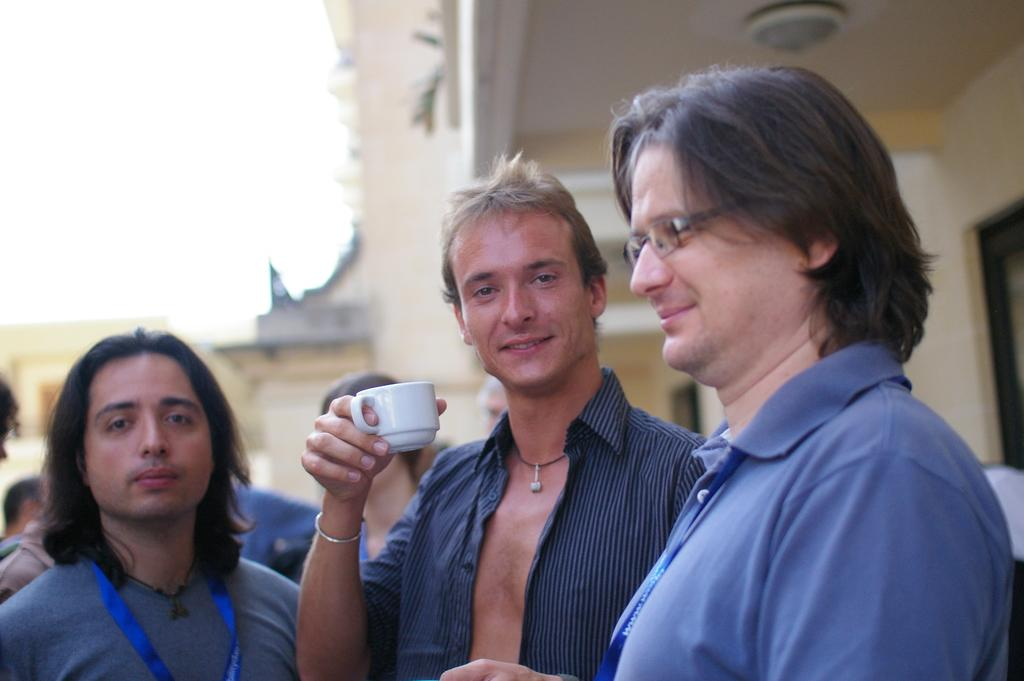How many people are in the image? There are people in the image, but the exact number is not specified. What is one person holding in the image? One person is holding a cup in the image. What type of structures can be seen in the image? There are buildings in the image. What can be seen in the background of the image? The sky is visible in the background of the image. What type of trousers is the person wearing in the image? There is no information about the type of trousers the person is wearing in the image. Can you tell me how many cords are connected to the buildings in the image? There is no mention of cords connected to the buildings in the image. 